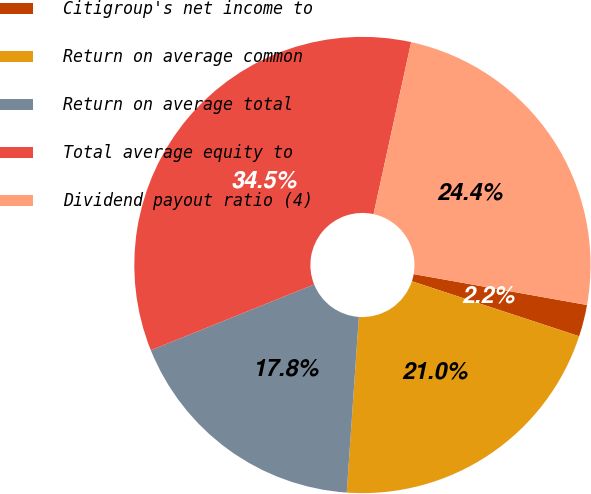Convert chart to OTSL. <chart><loc_0><loc_0><loc_500><loc_500><pie_chart><fcel>Citigroup's net income to<fcel>Return on average common<fcel>Return on average total<fcel>Total average equity to<fcel>Dividend payout ratio (4)<nl><fcel>2.25%<fcel>21.04%<fcel>17.81%<fcel>34.52%<fcel>24.38%<nl></chart> 